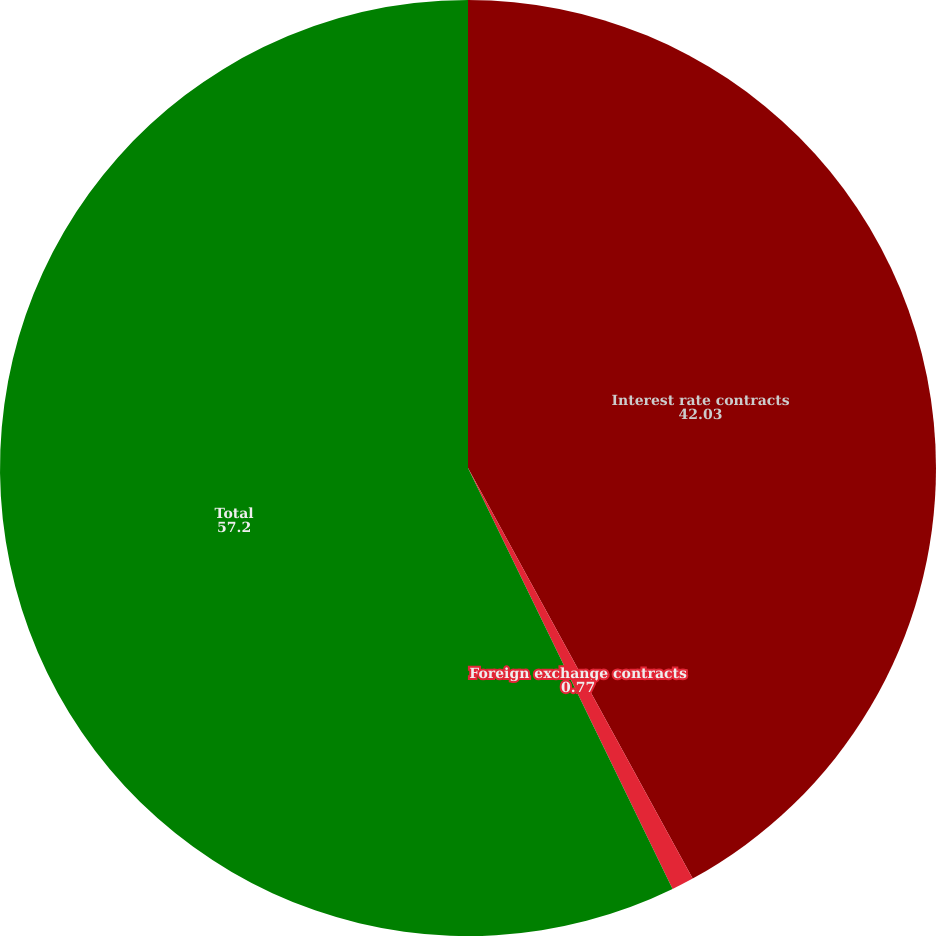<chart> <loc_0><loc_0><loc_500><loc_500><pie_chart><fcel>Interest rate contracts<fcel>Foreign exchange contracts<fcel>Total<nl><fcel>42.03%<fcel>0.77%<fcel>57.2%<nl></chart> 